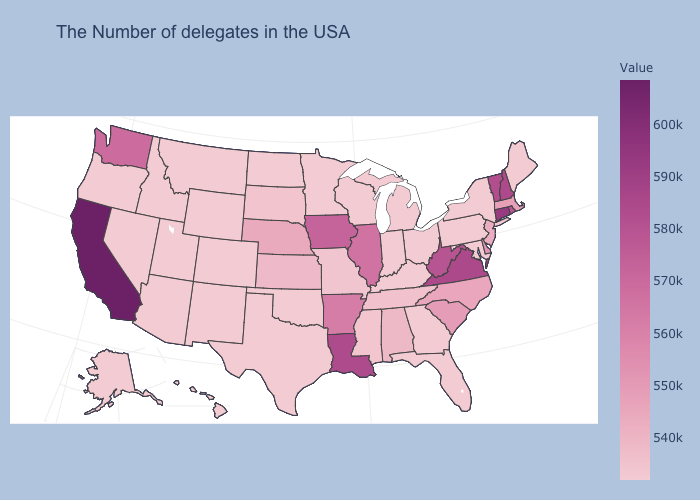Which states have the highest value in the USA?
Be succinct. California. Does the map have missing data?
Quick response, please. No. Among the states that border Montana , does South Dakota have the lowest value?
Give a very brief answer. No. Which states have the highest value in the USA?
Concise answer only. California. 